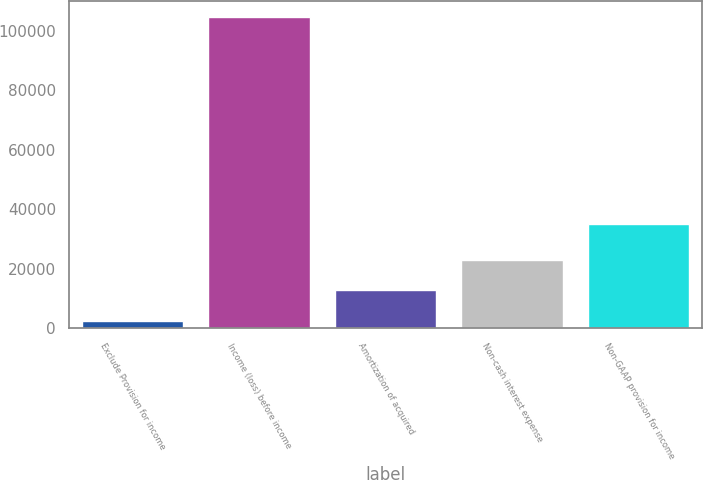Convert chart. <chart><loc_0><loc_0><loc_500><loc_500><bar_chart><fcel>Exclude Provision for income<fcel>Income (loss) before income<fcel>Amortization of acquired<fcel>Non-cash interest expense<fcel>Non-GAAP provision for income<nl><fcel>2641<fcel>104576<fcel>12834.5<fcel>23028<fcel>34967<nl></chart> 